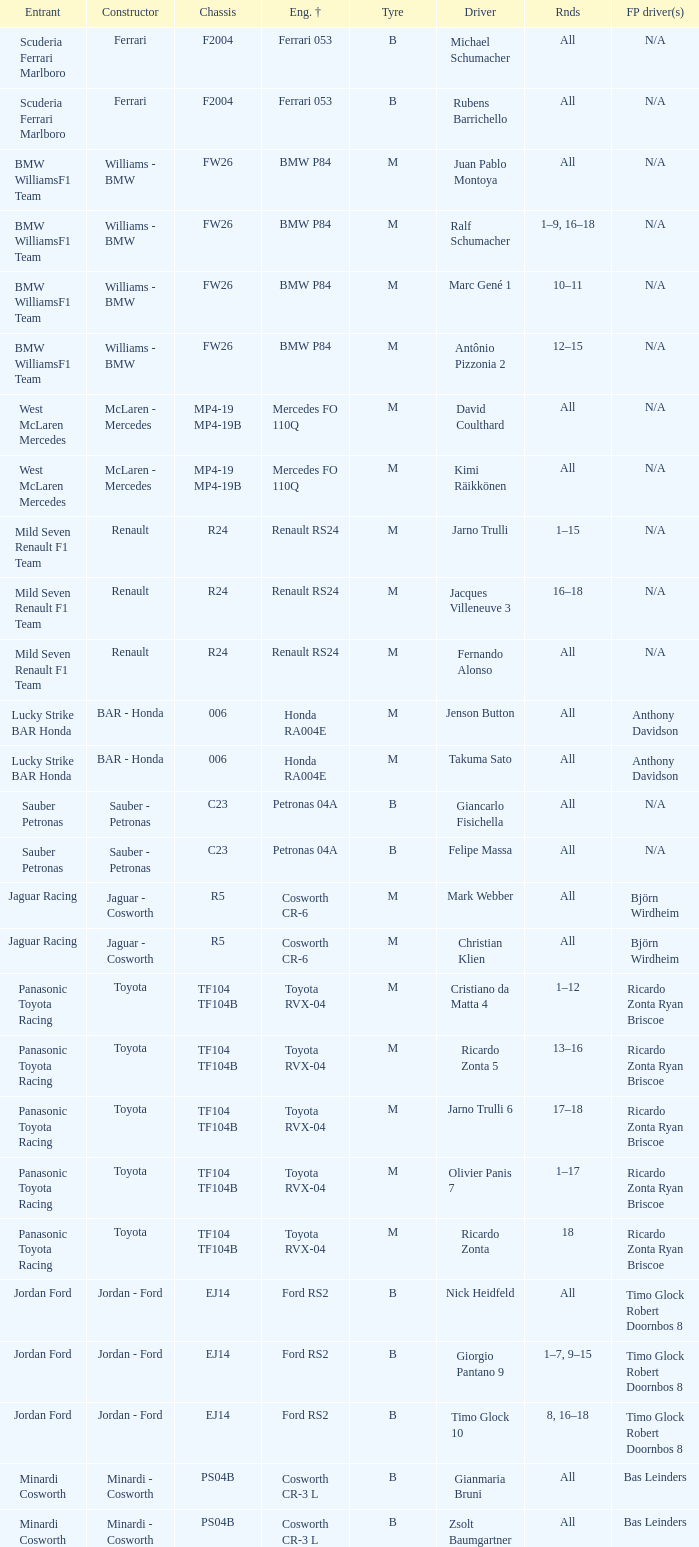What kind of free practice is there with a Ford RS2 engine +? Timo Glock Robert Doornbos 8, Timo Glock Robert Doornbos 8, Timo Glock Robert Doornbos 8. Give me the full table as a dictionary. {'header': ['Entrant', 'Constructor', 'Chassis', 'Eng. †', 'Tyre', 'Driver', 'Rnds', 'FP driver(s)'], 'rows': [['Scuderia Ferrari Marlboro', 'Ferrari', 'F2004', 'Ferrari 053', 'B', 'Michael Schumacher', 'All', 'N/A'], ['Scuderia Ferrari Marlboro', 'Ferrari', 'F2004', 'Ferrari 053', 'B', 'Rubens Barrichello', 'All', 'N/A'], ['BMW WilliamsF1 Team', 'Williams - BMW', 'FW26', 'BMW P84', 'M', 'Juan Pablo Montoya', 'All', 'N/A'], ['BMW WilliamsF1 Team', 'Williams - BMW', 'FW26', 'BMW P84', 'M', 'Ralf Schumacher', '1–9, 16–18', 'N/A'], ['BMW WilliamsF1 Team', 'Williams - BMW', 'FW26', 'BMW P84', 'M', 'Marc Gené 1', '10–11', 'N/A'], ['BMW WilliamsF1 Team', 'Williams - BMW', 'FW26', 'BMW P84', 'M', 'Antônio Pizzonia 2', '12–15', 'N/A'], ['West McLaren Mercedes', 'McLaren - Mercedes', 'MP4-19 MP4-19B', 'Mercedes FO 110Q', 'M', 'David Coulthard', 'All', 'N/A'], ['West McLaren Mercedes', 'McLaren - Mercedes', 'MP4-19 MP4-19B', 'Mercedes FO 110Q', 'M', 'Kimi Räikkönen', 'All', 'N/A'], ['Mild Seven Renault F1 Team', 'Renault', 'R24', 'Renault RS24', 'M', 'Jarno Trulli', '1–15', 'N/A'], ['Mild Seven Renault F1 Team', 'Renault', 'R24', 'Renault RS24', 'M', 'Jacques Villeneuve 3', '16–18', 'N/A'], ['Mild Seven Renault F1 Team', 'Renault', 'R24', 'Renault RS24', 'M', 'Fernando Alonso', 'All', 'N/A'], ['Lucky Strike BAR Honda', 'BAR - Honda', '006', 'Honda RA004E', 'M', 'Jenson Button', 'All', 'Anthony Davidson'], ['Lucky Strike BAR Honda', 'BAR - Honda', '006', 'Honda RA004E', 'M', 'Takuma Sato', 'All', 'Anthony Davidson'], ['Sauber Petronas', 'Sauber - Petronas', 'C23', 'Petronas 04A', 'B', 'Giancarlo Fisichella', 'All', 'N/A'], ['Sauber Petronas', 'Sauber - Petronas', 'C23', 'Petronas 04A', 'B', 'Felipe Massa', 'All', 'N/A'], ['Jaguar Racing', 'Jaguar - Cosworth', 'R5', 'Cosworth CR-6', 'M', 'Mark Webber', 'All', 'Björn Wirdheim'], ['Jaguar Racing', 'Jaguar - Cosworth', 'R5', 'Cosworth CR-6', 'M', 'Christian Klien', 'All', 'Björn Wirdheim'], ['Panasonic Toyota Racing', 'Toyota', 'TF104 TF104B', 'Toyota RVX-04', 'M', 'Cristiano da Matta 4', '1–12', 'Ricardo Zonta Ryan Briscoe'], ['Panasonic Toyota Racing', 'Toyota', 'TF104 TF104B', 'Toyota RVX-04', 'M', 'Ricardo Zonta 5', '13–16', 'Ricardo Zonta Ryan Briscoe'], ['Panasonic Toyota Racing', 'Toyota', 'TF104 TF104B', 'Toyota RVX-04', 'M', 'Jarno Trulli 6', '17–18', 'Ricardo Zonta Ryan Briscoe'], ['Panasonic Toyota Racing', 'Toyota', 'TF104 TF104B', 'Toyota RVX-04', 'M', 'Olivier Panis 7', '1–17', 'Ricardo Zonta Ryan Briscoe'], ['Panasonic Toyota Racing', 'Toyota', 'TF104 TF104B', 'Toyota RVX-04', 'M', 'Ricardo Zonta', '18', 'Ricardo Zonta Ryan Briscoe'], ['Jordan Ford', 'Jordan - Ford', 'EJ14', 'Ford RS2', 'B', 'Nick Heidfeld', 'All', 'Timo Glock Robert Doornbos 8'], ['Jordan Ford', 'Jordan - Ford', 'EJ14', 'Ford RS2', 'B', 'Giorgio Pantano 9', '1–7, 9–15', 'Timo Glock Robert Doornbos 8'], ['Jordan Ford', 'Jordan - Ford', 'EJ14', 'Ford RS2', 'B', 'Timo Glock 10', '8, 16–18', 'Timo Glock Robert Doornbos 8'], ['Minardi Cosworth', 'Minardi - Cosworth', 'PS04B', 'Cosworth CR-3 L', 'B', 'Gianmaria Bruni', 'All', 'Bas Leinders'], ['Minardi Cosworth', 'Minardi - Cosworth', 'PS04B', 'Cosworth CR-3 L', 'B', 'Zsolt Baumgartner', 'All', 'Bas Leinders']]} 